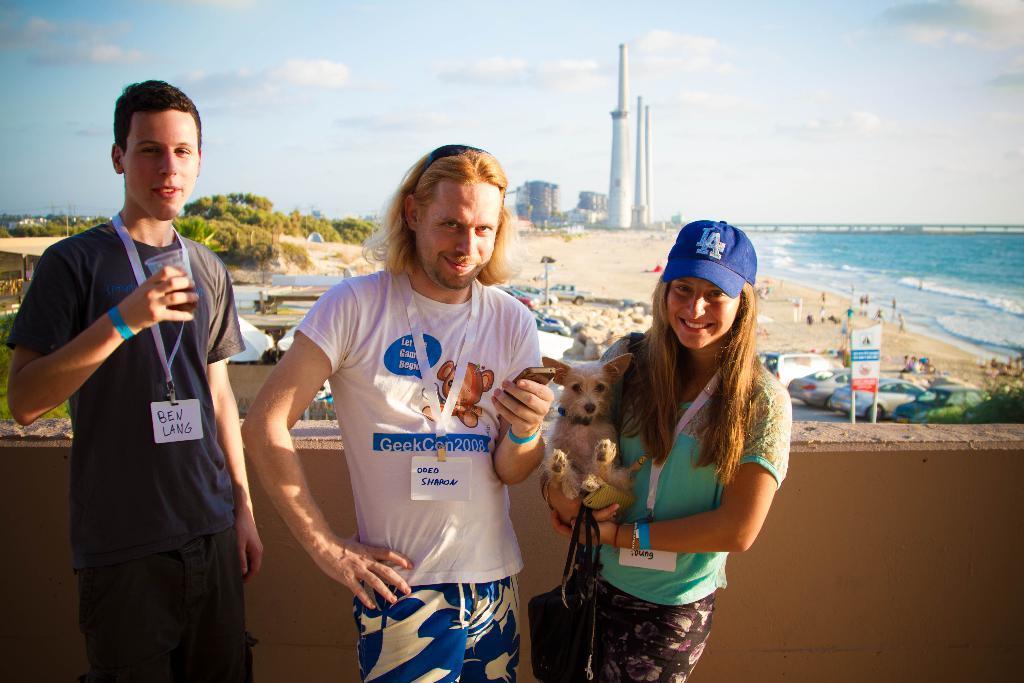Describe this image in one or two sentences. In the image we can see two men and a woman standing, wearing clothes, identity card and they are smiling. The woman is wearing cap and carrying a dog. The middle man is holding a device and the left side man is holding a glass. We can even see there are vehicles and trees. There are even other people wearing clothes. Here we can see the bridge, the sea, the tower and the cloudy sky. 